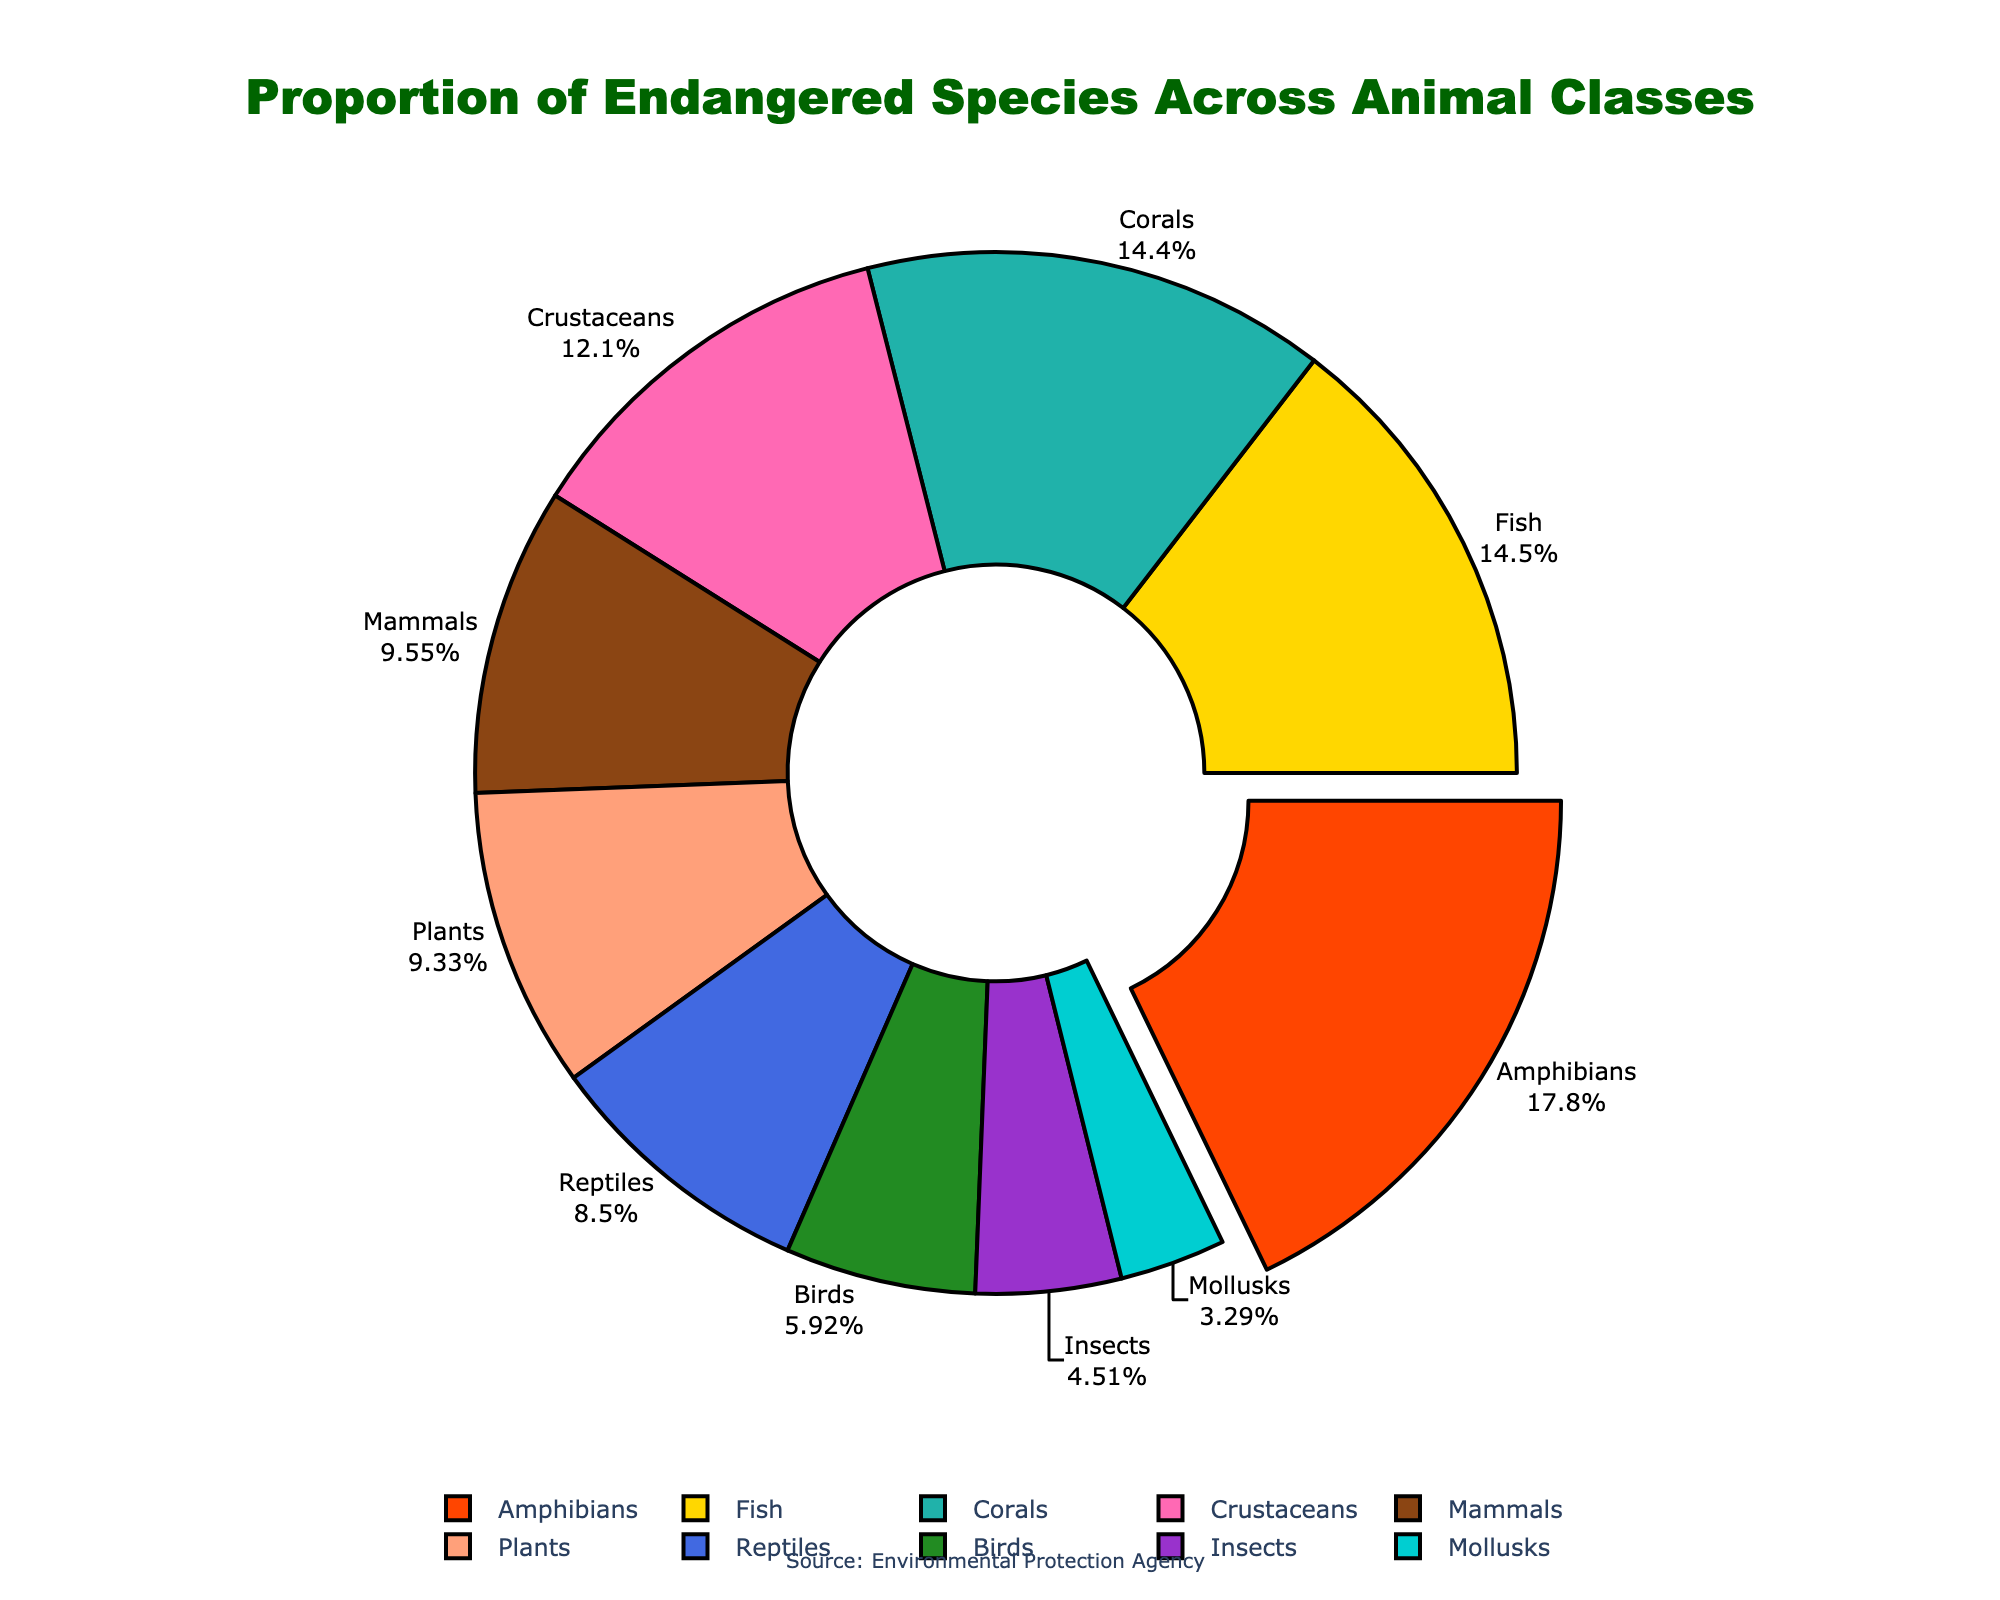What is the percentage of endangered amphibians? Look at the segment labeled "Amphibians" and note the percentage displayed next to it.
Answer: 40.7% Which class has the highest proportion of endangered species? Identify the segment with the largest area and check its label. It's the one that looks “pulled out” from the chart due to the specific visualization.
Answer: Amphibians Compare the proportion of endangered mammals to that of reptiles. Which is greater? Locate the segments for mammals and reptiles and compare their percentages: Mammals are at 21.8% and reptiles are at 19.4%.
Answer: Mammals What is the combined percentage for endangered fish and corals? Sum the percentages of the segments labeled "Fish" and "Corals": 33.2% + 32.9%.
Answer: 66.1% How much smaller is the proportion of endangered insects compared to crustaceans? Subtract the percentage of insects from that of crustaceans: 27.6% - 10.3%.
Answer: 17.3% What are the three classes with the lowest proportion of endangered species? Identify and list the three segments with the smallest area and their respective labels: Mollusks (7.5%), Insects (10.3%), and Birds (13.5%).
Answer: Mollusks, Insects, Birds Which segments are represented by different shades of green? Locate the segments colored with greenish tones in the figure and identify their labels.
Answer: Birds (darker green), Plants (lighter green) What is the total percentage for all the classes combined? Sum all the given percentages in the data: 21.8% + 13.5% + 19.4% + 40.7% + 33.2% + 10.3% + 7.5% + 27.6% + 32.9% + 21.3%.
Answer: 228.2% Compare the proportion of endangered mammals to the total percentage of endangered species in plants and corals combined. Which has the higher percentage? Add the proportions of plants (21.3%) and corals (32.9%) and compare the sum to that of mammals (21.8%): Plants + Corals = 54.2%, Mammals = 21.8%.
Answer: Plants and Corals What is the percentage difference between the highest and lowest segments? Find the difference between the highest percentage (Amphibians at 40.7%) and the lowest percentage (Mollusks at 7.5%). 40.7% - 7.5%.
Answer: 33.2% 